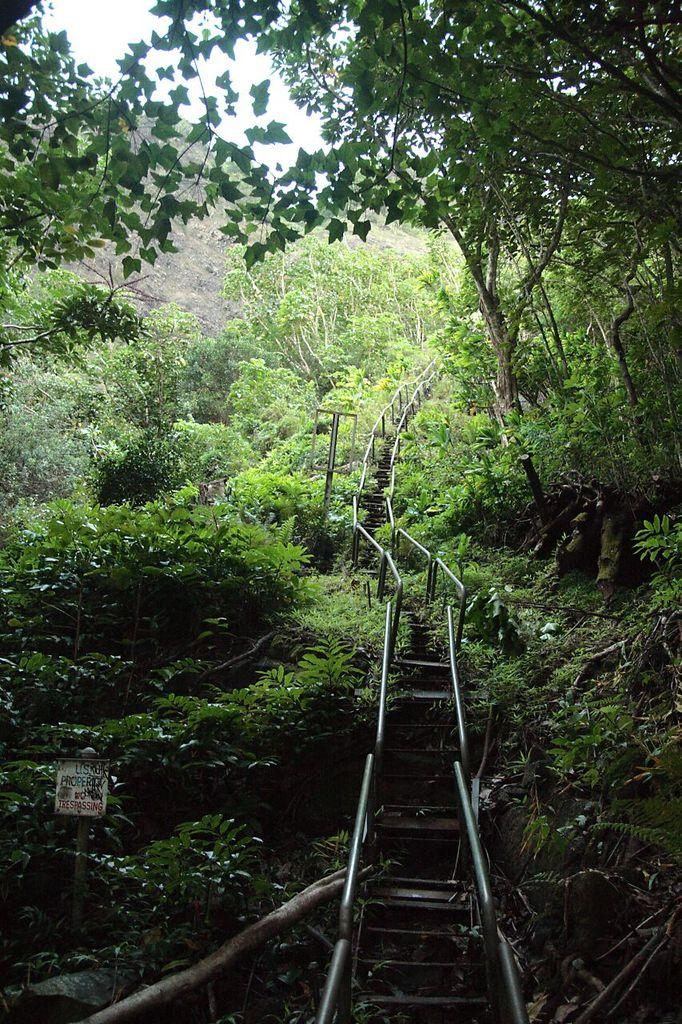What is the main feature in the center of the image? There are stairs in the center of the image. What safety feature do the stairs have? The stairs have railings. What can be seen on the left side of the image? There is a board on the left side of the image. What type of natural elements are visible in the image? There are trees visible in the image. What type of chin can be seen on the kitty in the image? There is no kitty present in the image, so there is no chin to describe. 